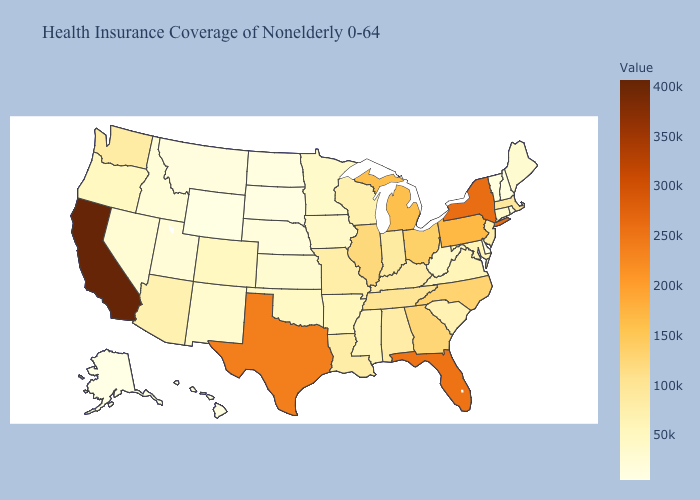Does Wyoming have a higher value than Virginia?
Short answer required. No. Does Alaska have the lowest value in the USA?
Give a very brief answer. Yes. Which states have the highest value in the USA?
Concise answer only. California. Which states have the highest value in the USA?
Write a very short answer. California. Is the legend a continuous bar?
Quick response, please. Yes. Does Tennessee have the highest value in the South?
Write a very short answer. No. Does Nevada have the highest value in the West?
Concise answer only. No. 